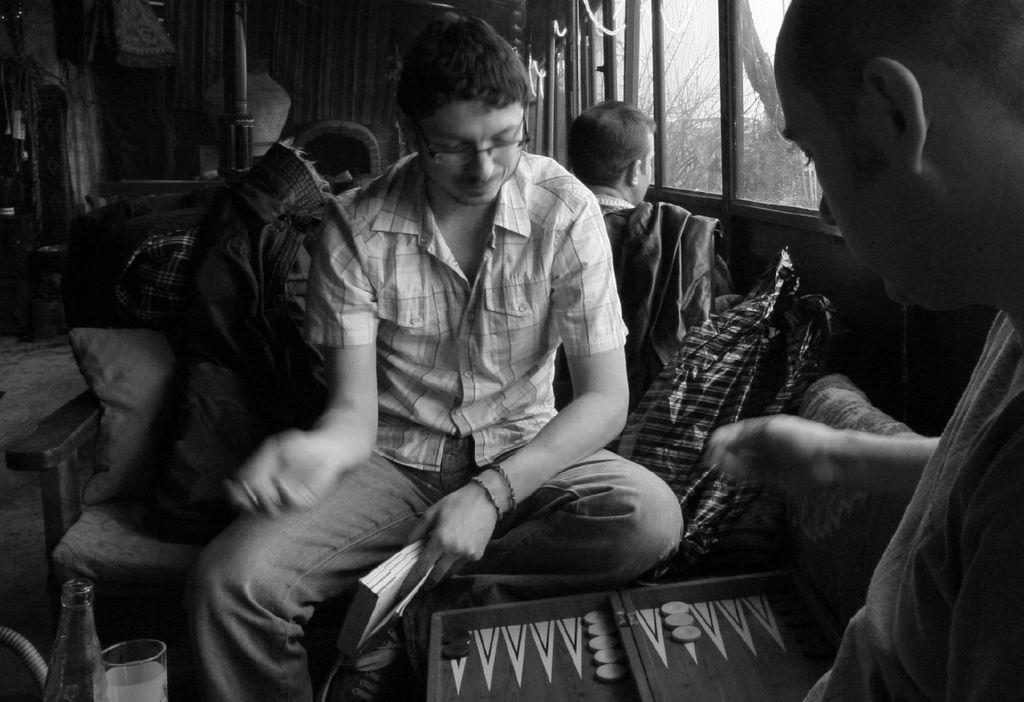How many people are in the image? There is a group of people in the image. What is the man holding in his hand? The man is holding a book in his hand. What expression does the man have? The man is smiling. What objects related to drinking can be seen in the image? There is a bottle and a glass in the image. What can be seen through the windows in the background of the image? Trees are visible through the windows in the background of the image. What type of throat-soothing remedy can be seen in the image? There is no throat-soothing remedy present in the image. What observation can be made about the man's ability to levitate in the image? There is no indication of the man levitating in the image. 